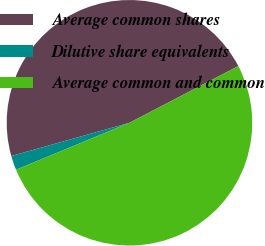<chart> <loc_0><loc_0><loc_500><loc_500><pie_chart><fcel>Average common shares<fcel>Dilutive share equivalents<fcel>Average common and common<nl><fcel>46.72%<fcel>1.88%<fcel>51.39%<nl></chart> 